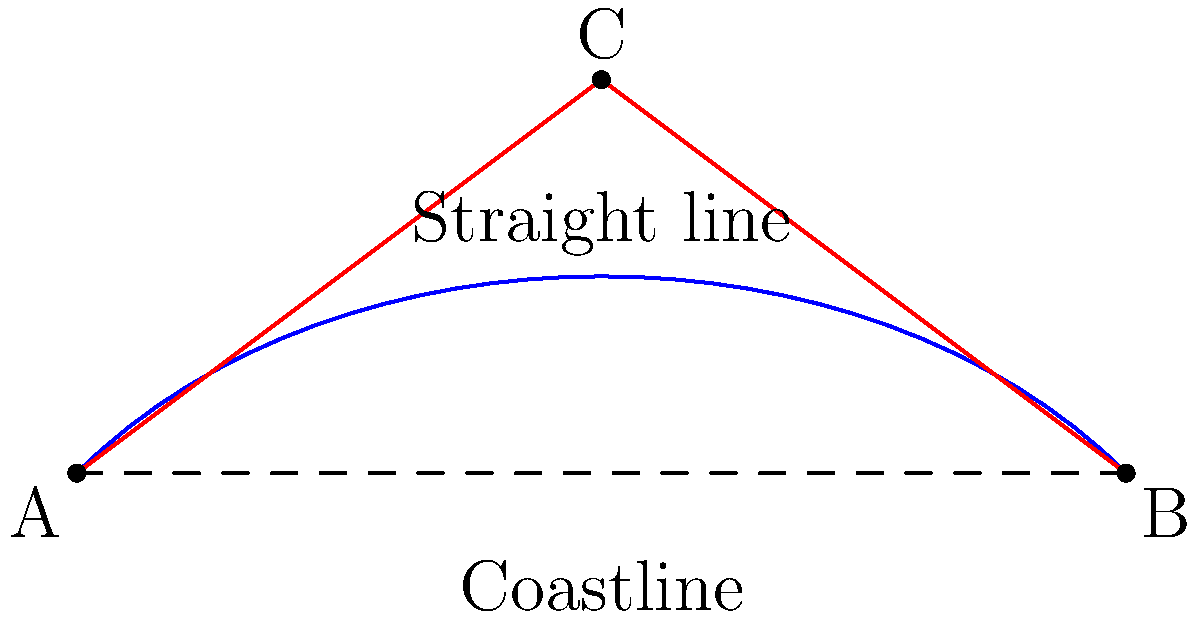As a marine scientist studying ocean currents along a curved coastline, you need to determine the shortest distance between two points A and B. The coastline follows a curved path, but you can use plane geometry to simplify the problem. Given that the straight-line distance between A and B is 8 units, and the perpendicular distance from the midpoint of AB to the curve at point C is 3 units, calculate the length of the path ACB to the nearest tenth of a unit. To solve this problem, we can use the properties of right triangles and the Pythagorean theorem. Let's break it down step-by-step:

1) The straight line AB is 8 units long, so its midpoint is at 4 units from both A and B.

2) Point C is 3 units perpendicular to the midpoint of AB. This creates two right triangles: ACD and BCD, where D is the midpoint of AB.

3) In either of these right triangles:
   - The base (half of AB) is 4 units
   - The height (DC) is 3 units

4) We can use the Pythagorean theorem to find the length of AC (which is equal to BC):

   $$AC^2 = 4^2 + 3^2$$
   $$AC^2 = 16 + 9 = 25$$
   $$AC = \sqrt{25} = 5$$

5) Since AC = BC = 5 units, the total length of the path ACB is:

   $$ACB = AC + CB = 5 + 5 = 10$$ units

6) The question asks for the answer to the nearest tenth, but 10 is already a whole number, so no rounding is necessary.
Answer: 10 units 